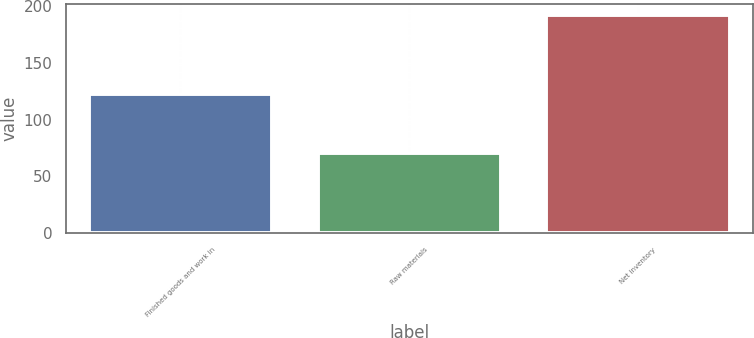Convert chart to OTSL. <chart><loc_0><loc_0><loc_500><loc_500><bar_chart><fcel>Finished goods and work in<fcel>Raw materials<fcel>Net inventory<nl><fcel>122.3<fcel>70.3<fcel>192.6<nl></chart> 